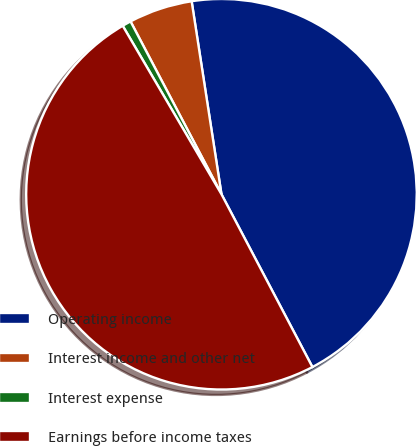Convert chart. <chart><loc_0><loc_0><loc_500><loc_500><pie_chart><fcel>Operating income<fcel>Interest income and other net<fcel>Interest expense<fcel>Earnings before income taxes<nl><fcel>44.73%<fcel>5.27%<fcel>0.73%<fcel>49.27%<nl></chart> 